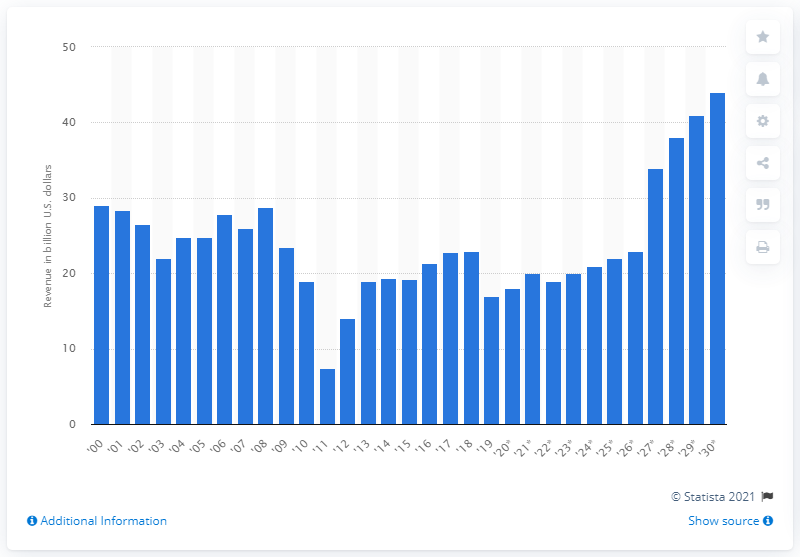Outline some significant characteristics in this image. The forecast predicts an increase in estate and gift tax revenue up to $44 million in U.S. dollars in 2030. In 2018, the amount of revenue generated from estate and gift taxes was $17... 